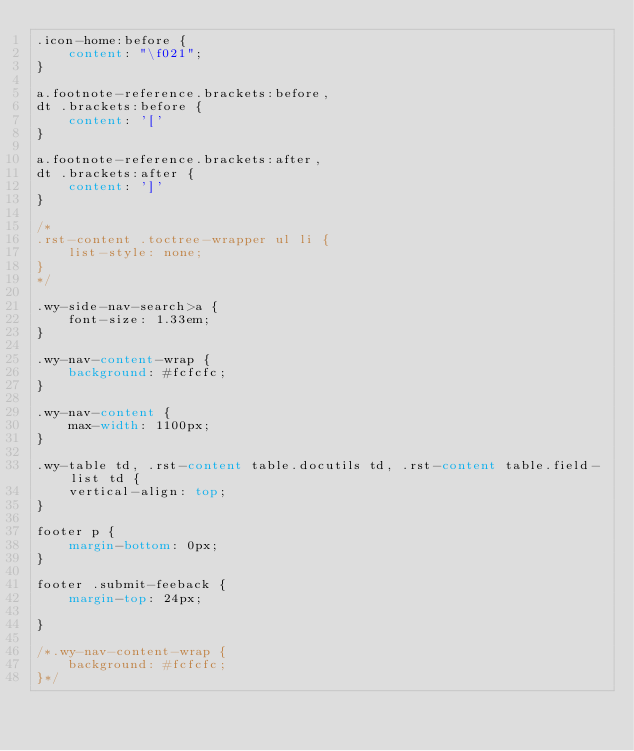<code> <loc_0><loc_0><loc_500><loc_500><_CSS_>.icon-home:before {
    content: "\f021";
}

a.footnote-reference.brackets:before,
dt .brackets:before {
    content: '['
}

a.footnote-reference.brackets:after,
dt .brackets:after {
    content: ']'
}

/*
.rst-content .toctree-wrapper ul li {
    list-style: none;
}
*/

.wy-side-nav-search>a {
    font-size: 1.33em;
}

.wy-nav-content-wrap {
    background: #fcfcfc;
}

.wy-nav-content {
    max-width: 1100px;
}

.wy-table td, .rst-content table.docutils td, .rst-content table.field-list td {
    vertical-align: top;
}

footer p {
    margin-bottom: 0px;
}

footer .submit-feeback {
    margin-top: 24px;

}

/*.wy-nav-content-wrap {
    background: #fcfcfc;
}*/
</code> 